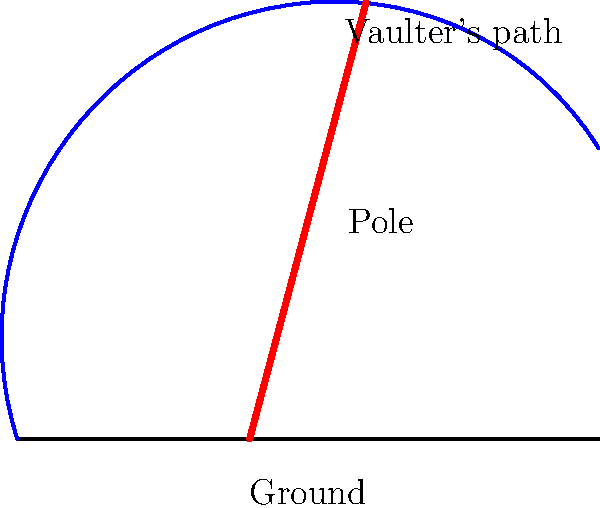In pole vaulting, the pole bends significantly during the vault. How does this bending affect the vaulter's ability to clear the bar? The bending of the pole in pole vaulting plays a crucial role in the athlete's performance. Here's a step-by-step explanation of its effects:

1. Energy storage: As the vaulter plants the pole and begins to rise, the pole bends, storing elastic potential energy.

2. Catapult effect: When the pole straightens, it converts the stored elastic potential energy into kinetic energy, propelling the vaulter upward.

3. Increased time: The bending of the pole increases the time the vaulter spends in contact with it, allowing for a greater transfer of energy.

4. Higher vault: The additional energy and upward momentum provided by the pole's straightening allow the vaulter to reach greater heights.

5. Center of mass: The bending pole enables the vaulter to raise their center of mass higher before releasing the pole.

6. Timing: The flexibility of the pole requires precise timing from the vaulter to maximize the energy transfer and achieve optimal height.

7. Materials: Modern poles are made of flexible materials like fiberglass or carbon fiber to enhance this bending effect.

The physics behind this involves the conversion of energy forms:
$$ E_{total} = E_{kinetic} + E_{potential_{elastic}} + E_{potential_{gravitational}} $$

As the pole bends, $E_{potential_{elastic}}$ increases. When it straightens, this energy is converted to $E_{kinetic}$, which then becomes $E_{potential_{gravitational}}$ as the vaulter rises.
Answer: The pole's bending stores elastic potential energy, which is converted to kinetic energy, propelling the vaulter higher. 